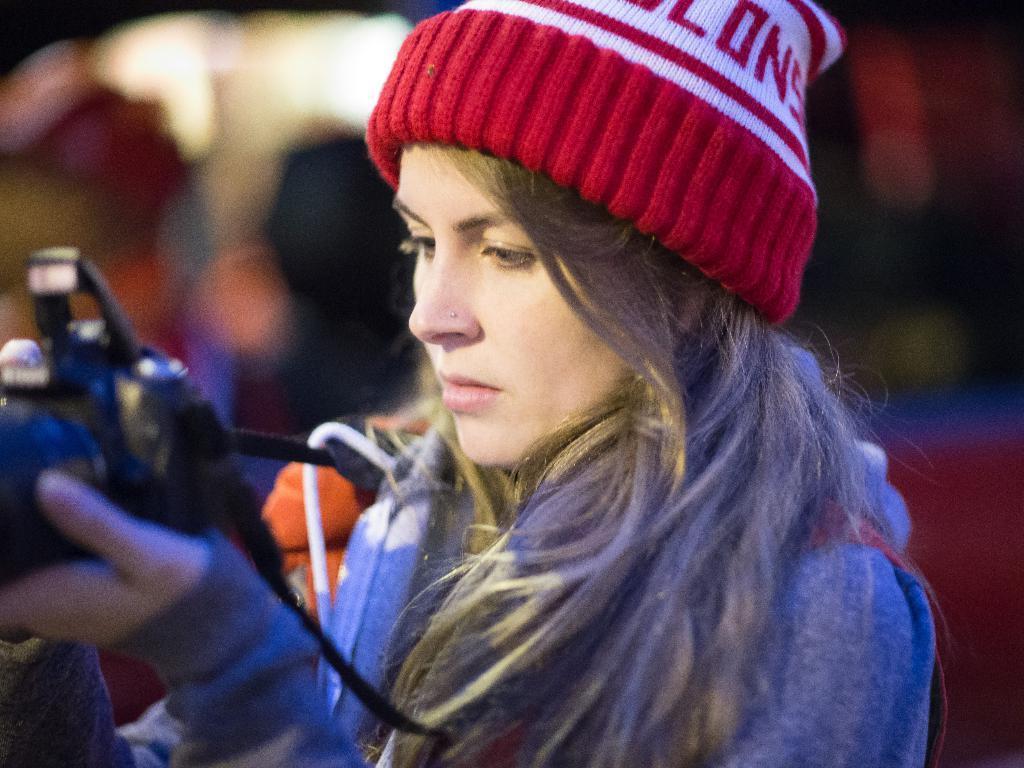How would you summarize this image in a sentence or two? In this picture we can see a woman holding camera. 